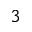<formula> <loc_0><loc_0><loc_500><loc_500>^ { 3 }</formula> 